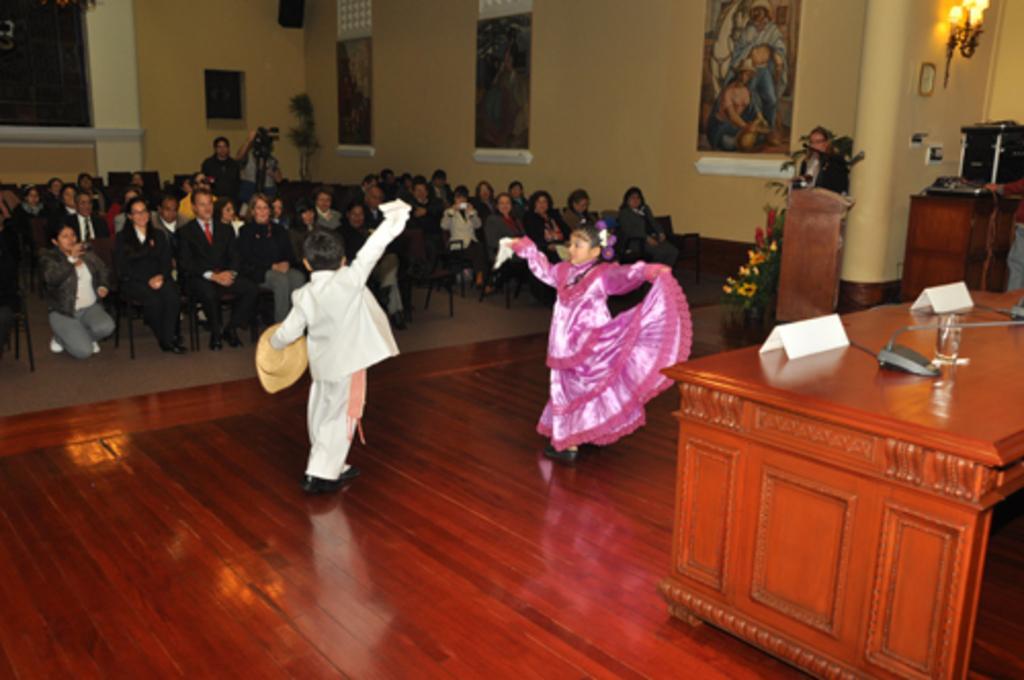Can you describe this image briefly? In this image there are group of people sitting in chair , a boy and a girl dancing and back ground there is frame attached to wall, lamp , table , name board , glass, plant. 